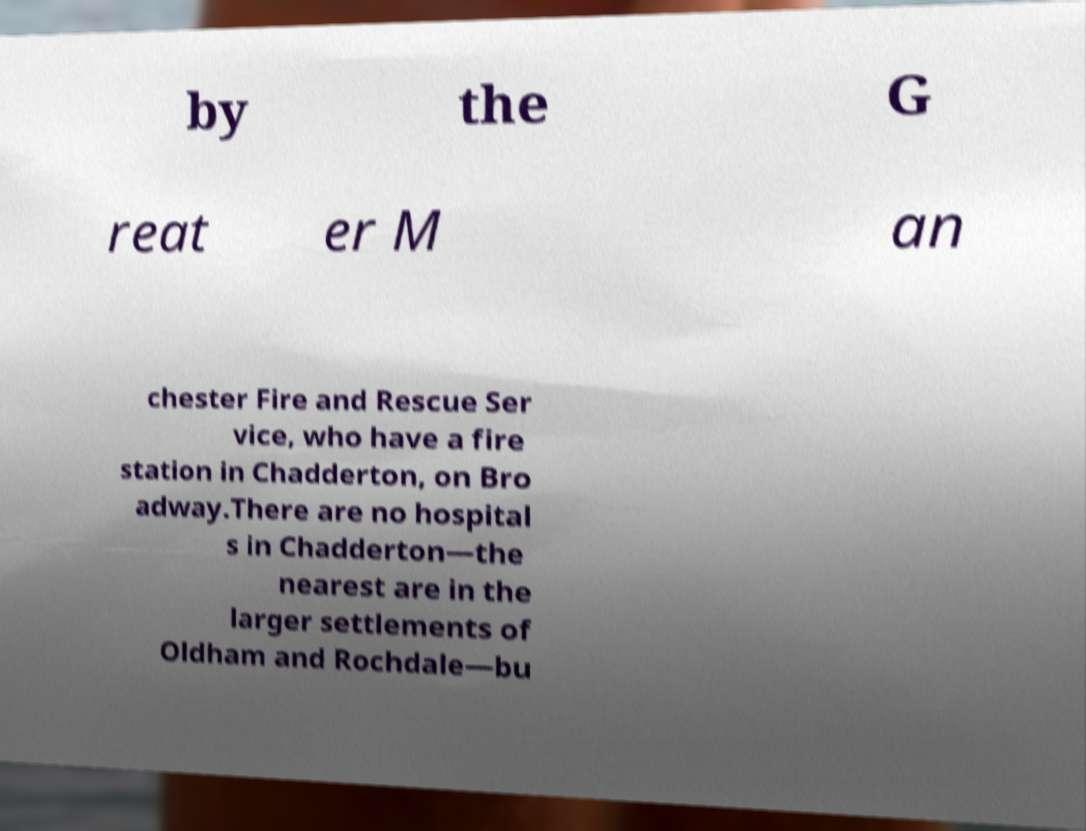Can you accurately transcribe the text from the provided image for me? by the G reat er M an chester Fire and Rescue Ser vice, who have a fire station in Chadderton, on Bro adway.There are no hospital s in Chadderton—the nearest are in the larger settlements of Oldham and Rochdale—bu 